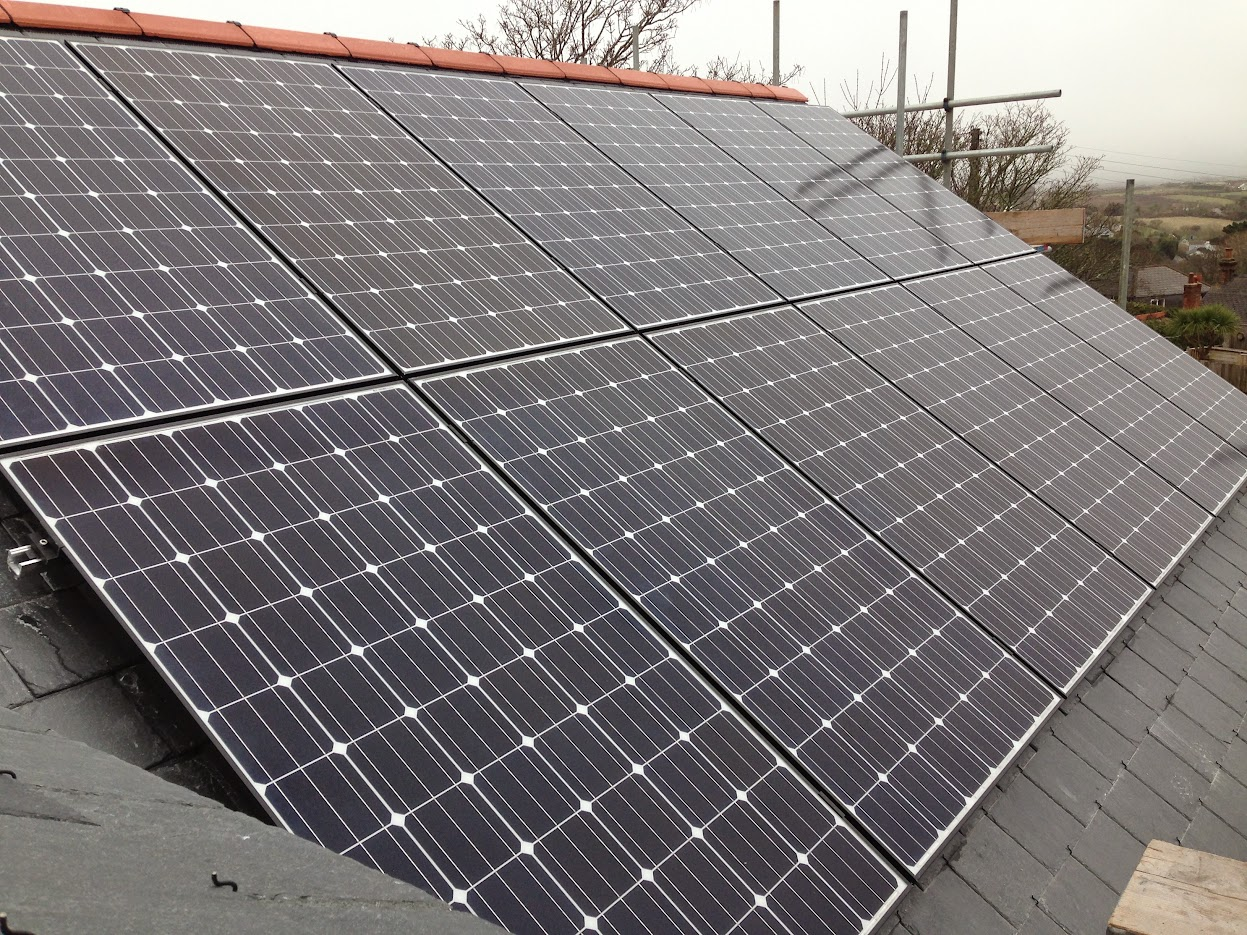Could environmental factors impact the performance of these solar panels? Yes, environmental factors significantly impact solar panel performance. Issues such as shading from surrounding trees or buildings, dust, and bird droppings can obstruct sunlight and reduce output. Regular maintenance and strategic placement to minimize shading are essential for maintaining optimal performance. 